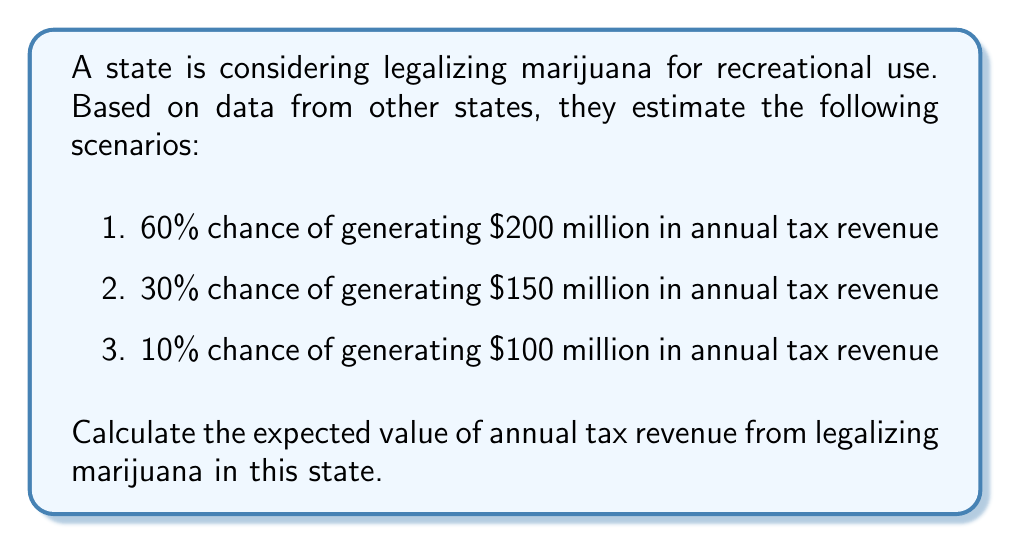Can you solve this math problem? To calculate the expected value, we need to multiply each possible outcome by its probability and then sum these products. Let's break it down step-by-step:

1. For the first scenario:
   Probability = 60% = 0.60
   Revenue = $200 million
   $$E_1 = 0.60 \times 200 = 120$$ million

2. For the second scenario:
   Probability = 30% = 0.30
   Revenue = $150 million
   $$E_2 = 0.30 \times 150 = 45$$ million

3. For the third scenario:
   Probability = 10% = 0.10
   Revenue = $100 million
   $$E_3 = 0.10 \times 100 = 10$$ million

4. The expected value is the sum of these individual expectations:
   $$E(\text{Revenue}) = E_1 + E_2 + E_3$$
   $$E(\text{Revenue}) = 120 + 45 + 10 = 175$$ million

Therefore, the expected value of annual tax revenue from legalizing marijuana in this state is $175 million.
Answer: $175 million 